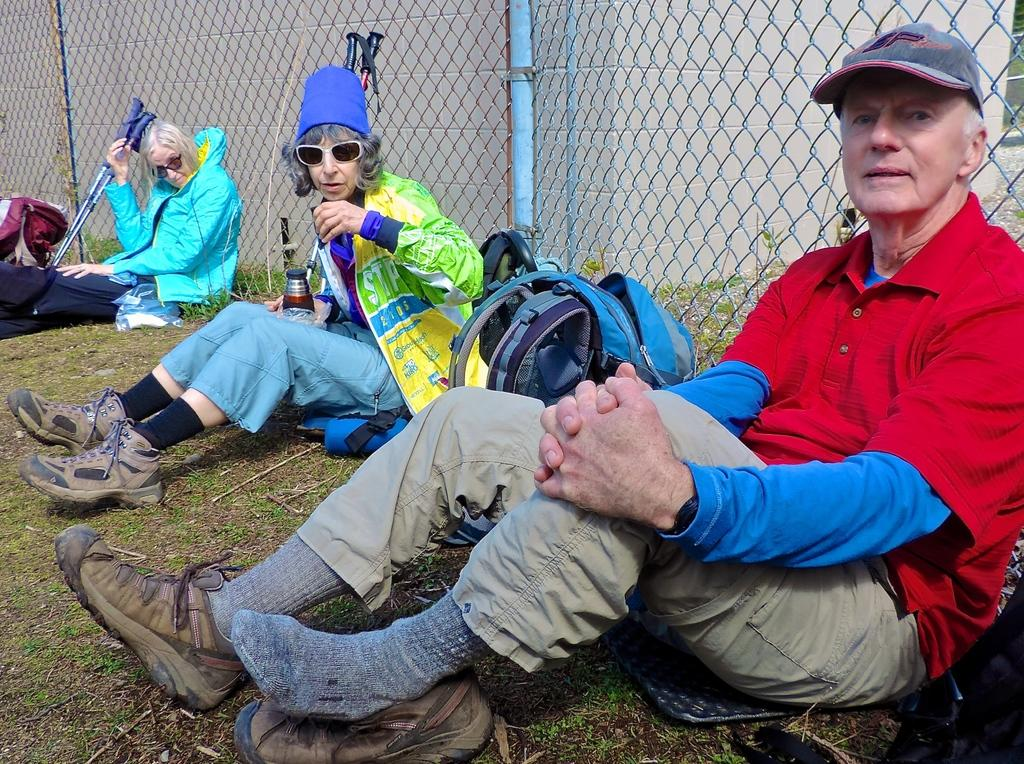How many people are sitting on the land in the image? There are three members sitting on the land in the image. What can be seen in the background of the image? There is a fence and a wall visible in the background. What type of cactus can be seen growing near the wall in the image? There is no cactus present in the image; only the fence, wall, and the three members sitting on the land are visible. 